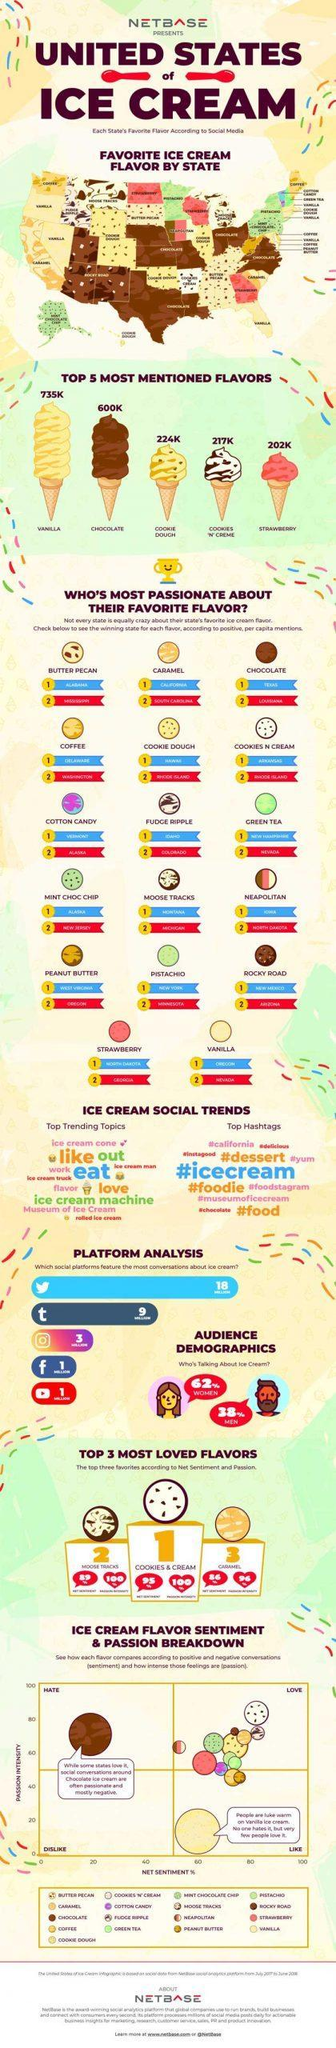Audience from which gender talk more about Ice cream?
Answer the question with a short phrase. Women Which is the second most mentioned ice cream flavor? Chocolate Which flavor has 202K mentions? strawberry Which social media platform features most conversations about ice cream - facebook, twitter or instagram? twitter Which is the top trending hashtag? #icecream How many mentions for vanilla flavor? 735K How many ice-cream flavors are listed in this image? 17 